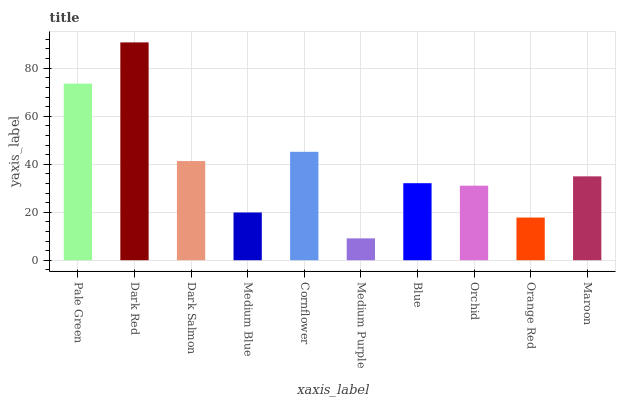Is Medium Purple the minimum?
Answer yes or no. Yes. Is Dark Red the maximum?
Answer yes or no. Yes. Is Dark Salmon the minimum?
Answer yes or no. No. Is Dark Salmon the maximum?
Answer yes or no. No. Is Dark Red greater than Dark Salmon?
Answer yes or no. Yes. Is Dark Salmon less than Dark Red?
Answer yes or no. Yes. Is Dark Salmon greater than Dark Red?
Answer yes or no. No. Is Dark Red less than Dark Salmon?
Answer yes or no. No. Is Maroon the high median?
Answer yes or no. Yes. Is Blue the low median?
Answer yes or no. Yes. Is Orange Red the high median?
Answer yes or no. No. Is Orchid the low median?
Answer yes or no. No. 